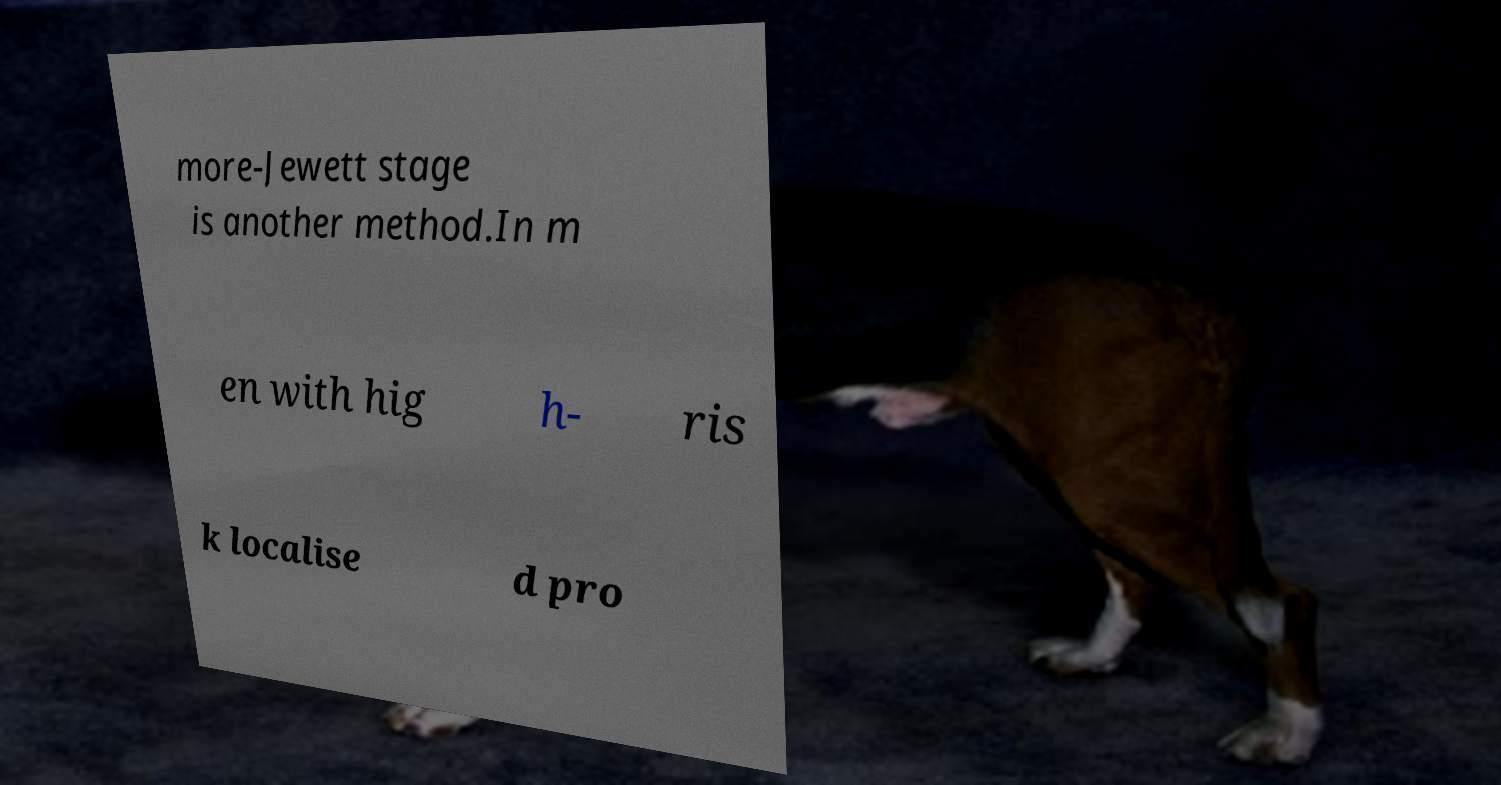Can you read and provide the text displayed in the image?This photo seems to have some interesting text. Can you extract and type it out for me? more-Jewett stage is another method.In m en with hig h- ris k localise d pro 